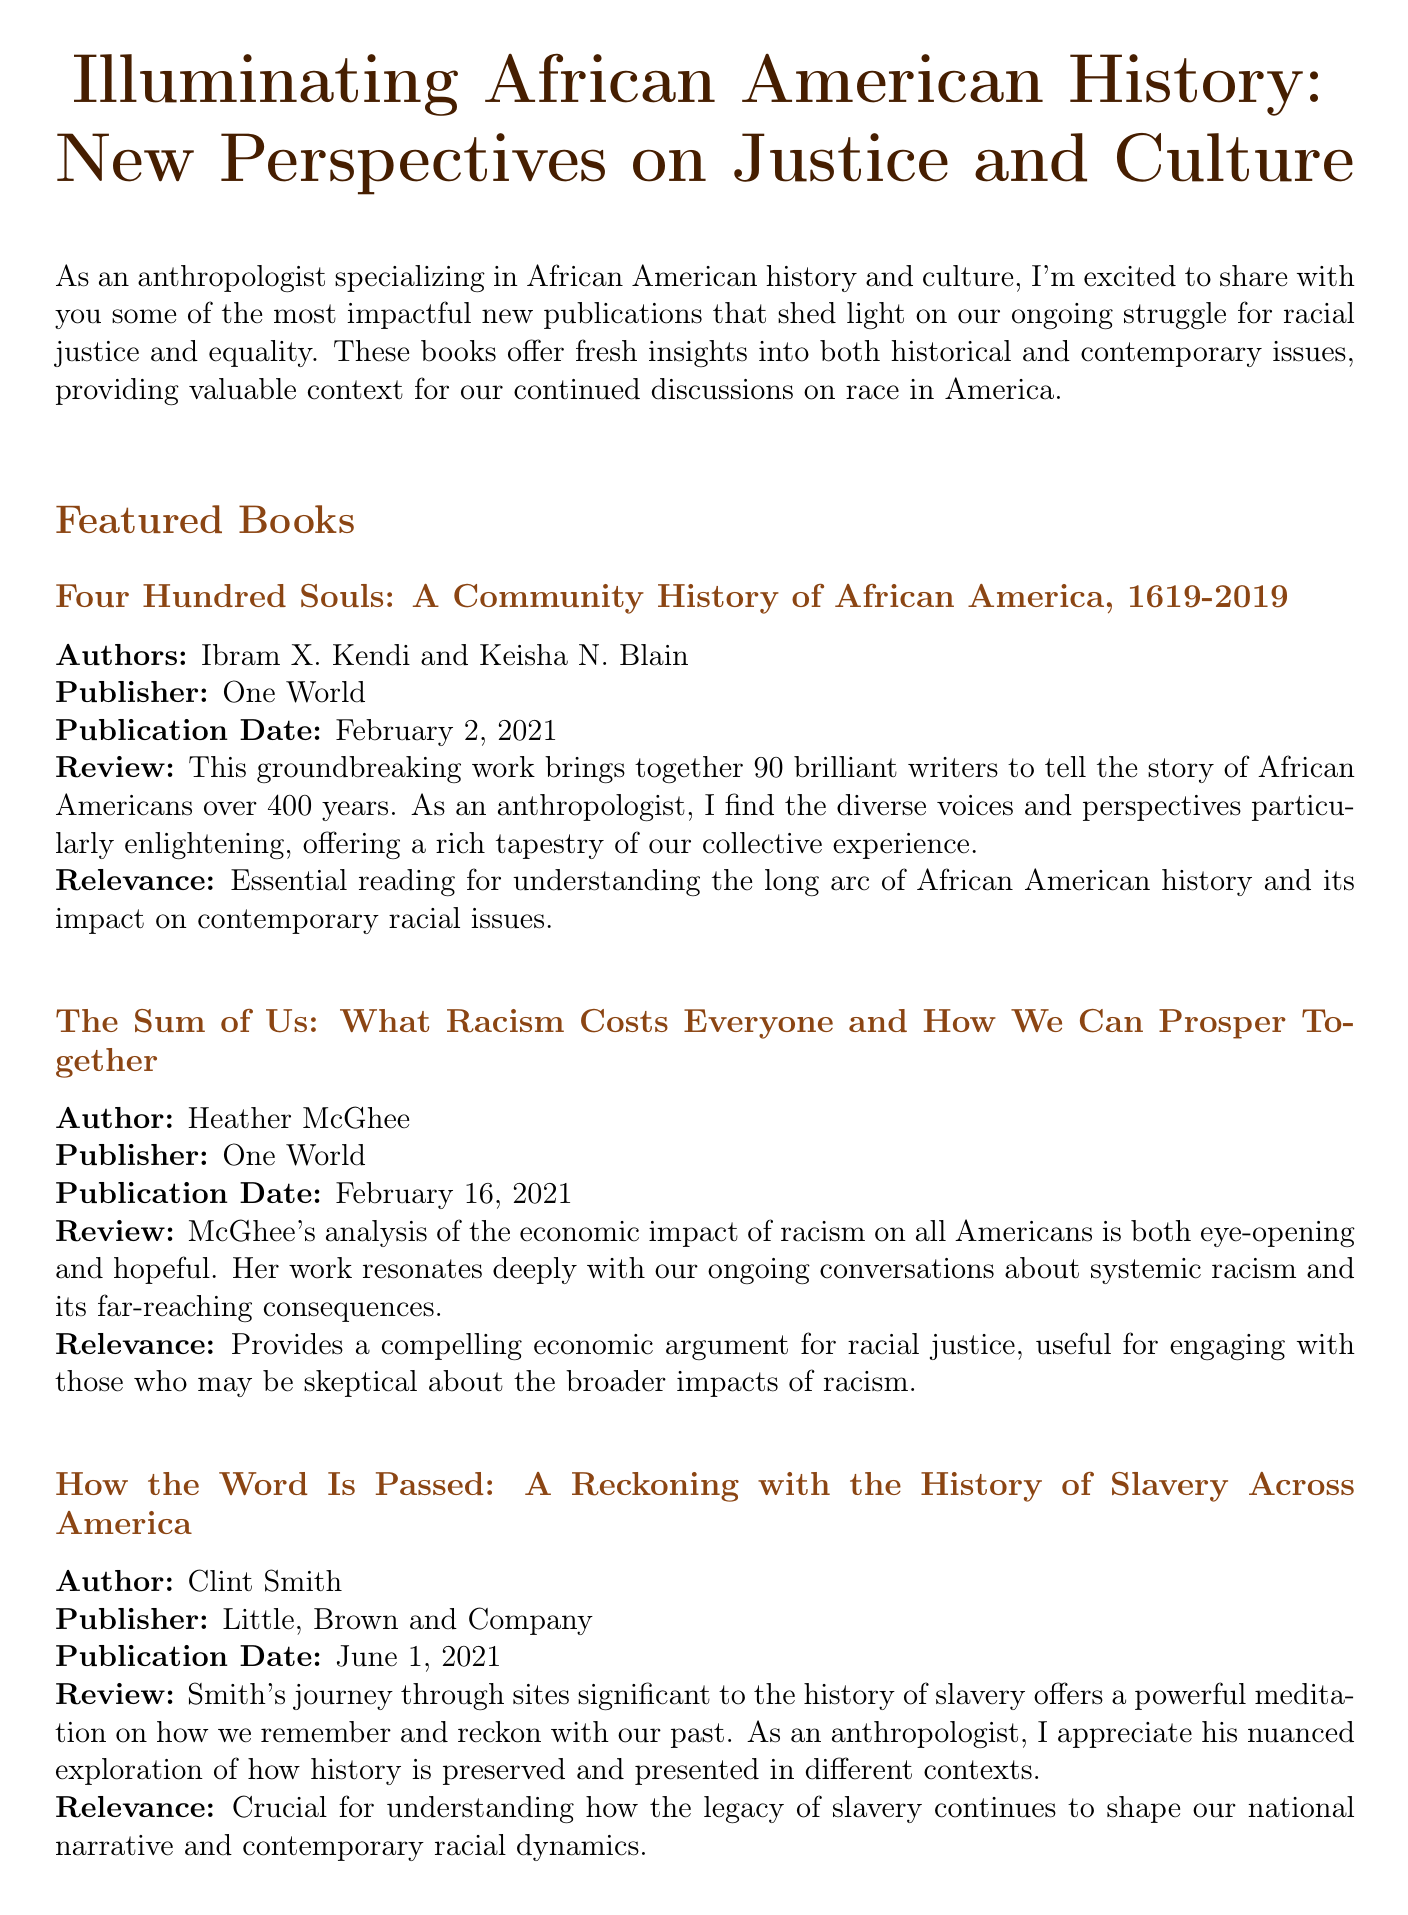What is the title of the newsletter? The title is presented prominently at the beginning of the document.
Answer: Illuminating African American History: New Perspectives on Justice and Culture Who are the authors of "Four Hundred Souls"? The document lists the authors directly under the book title in the featured books section.
Answer: Ibram X. Kendi and Keisha N. Blain When is the upcoming ASALH meeting? The date of the event is clearly mentioned in the upcoming events section.
Answer: September 28 - October 2, 2023 What is the primary theme of the ASALH conference this year? The theme is highlighted in the description of the event in the document.
Answer: Black Resistance What publisher released "The Sum of Us"? The publisher information is included in the book details in the newsletter.
Answer: One World What type of resource is "The HistoryMakers"? The type of resource is specified in the additional resources section.
Answer: Online Database How many writers contributed to "Four Hundred Souls"? The number of writers contributing to the book is mentioned in the review section.
Answer: 90 What does Clint Smith's book focus on? The review provides insight into the main focus of the book.
Answer: The history of slavery across America 